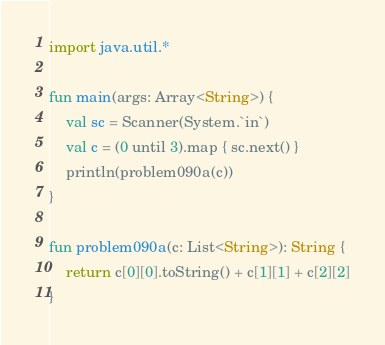Convert code to text. <code><loc_0><loc_0><loc_500><loc_500><_Kotlin_>import java.util.*

fun main(args: Array<String>) {
    val sc = Scanner(System.`in`)
    val c = (0 until 3).map { sc.next() }
    println(problem090a(c))
}

fun problem090a(c: List<String>): String {
    return c[0][0].toString() + c[1][1] + c[2][2]
}</code> 